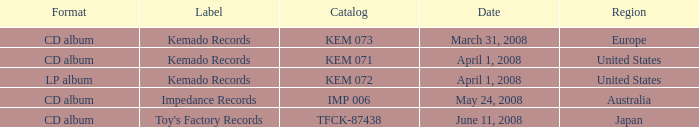Which Format has a Date of may 24, 2008? CD album. 